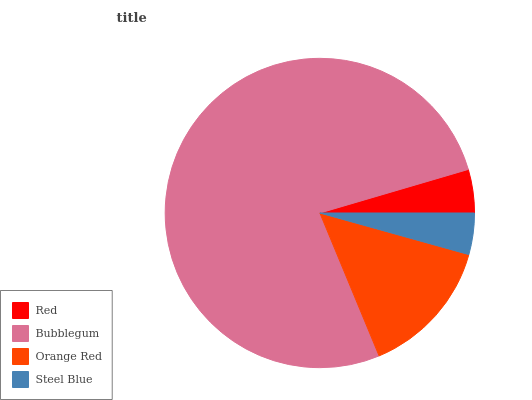Is Steel Blue the minimum?
Answer yes or no. Yes. Is Bubblegum the maximum?
Answer yes or no. Yes. Is Orange Red the minimum?
Answer yes or no. No. Is Orange Red the maximum?
Answer yes or no. No. Is Bubblegum greater than Orange Red?
Answer yes or no. Yes. Is Orange Red less than Bubblegum?
Answer yes or no. Yes. Is Orange Red greater than Bubblegum?
Answer yes or no. No. Is Bubblegum less than Orange Red?
Answer yes or no. No. Is Orange Red the high median?
Answer yes or no. Yes. Is Red the low median?
Answer yes or no. Yes. Is Steel Blue the high median?
Answer yes or no. No. Is Bubblegum the low median?
Answer yes or no. No. 